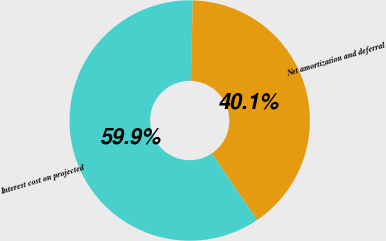Convert chart. <chart><loc_0><loc_0><loc_500><loc_500><pie_chart><fcel>Interest cost on projected<fcel>Net amortization and deferral<nl><fcel>59.9%<fcel>40.1%<nl></chart> 